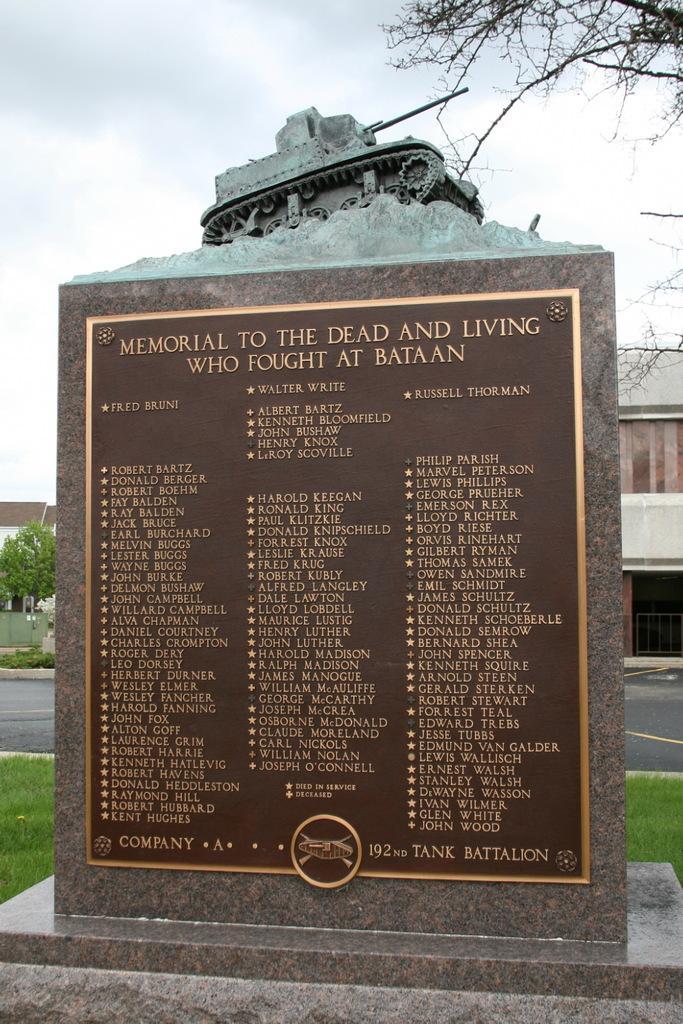Please provide a concise description of this image. In this image we can see the grave with text and on that we can see the sculpture. And at the back there are trees, building, grass, road and the sky. 